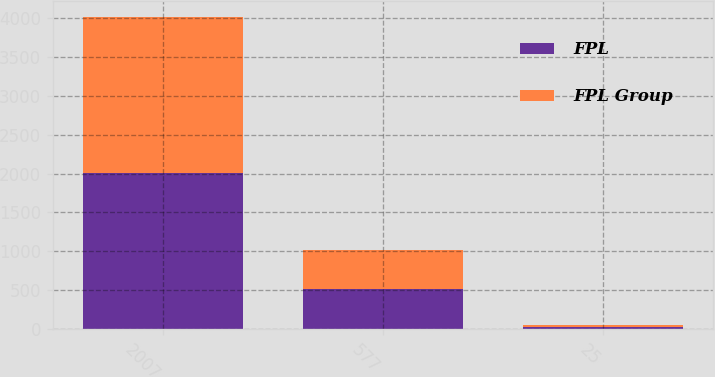<chart> <loc_0><loc_0><loc_500><loc_500><stacked_bar_chart><ecel><fcel>2007<fcel>577<fcel>25<nl><fcel>FPL<fcel>2006<fcel>522<fcel>31<nl><fcel>FPL Group<fcel>2007<fcel>491<fcel>18<nl></chart> 